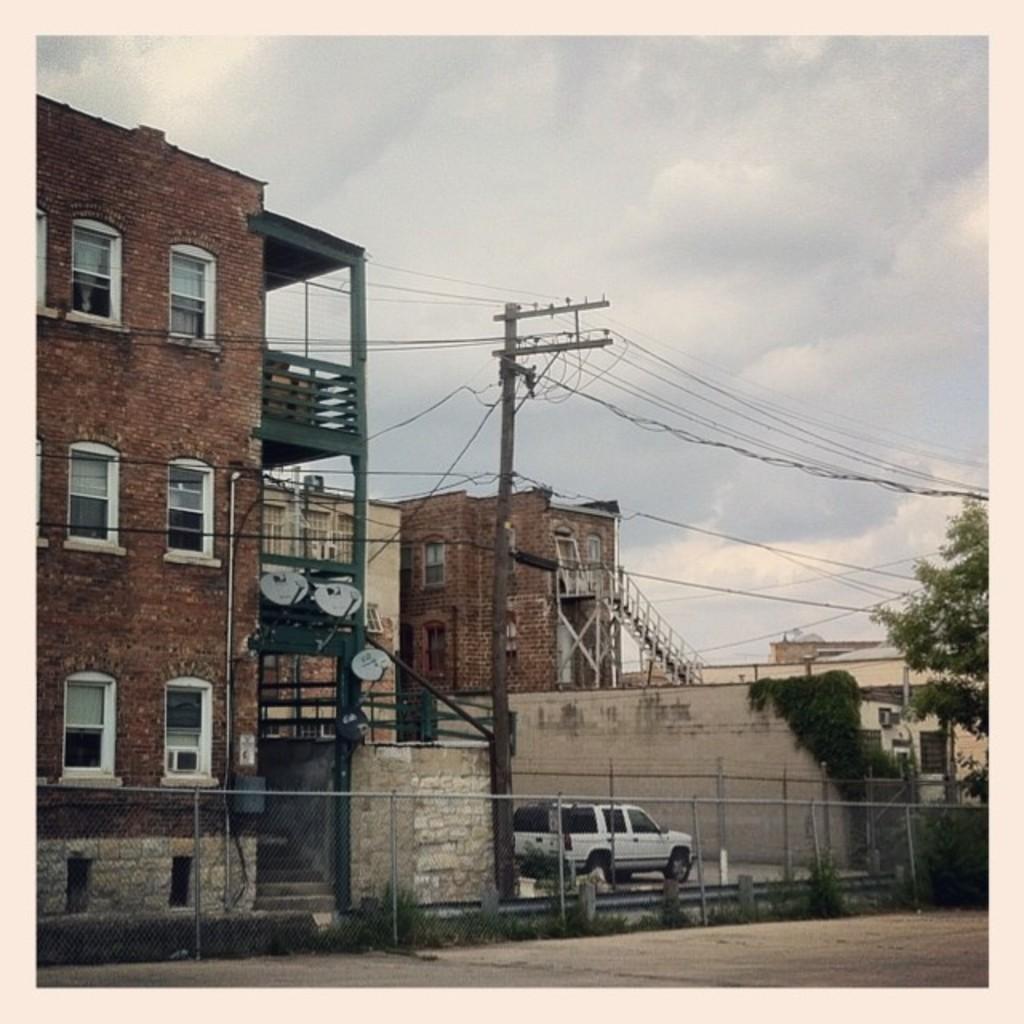Please provide a concise description of this image. In this picture I can see buildings, trees and a mini truck and I can see a pole and stairs and a cloudy sky. 